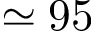Convert formula to latex. <formula><loc_0><loc_0><loc_500><loc_500>\simeq 9 5</formula> 